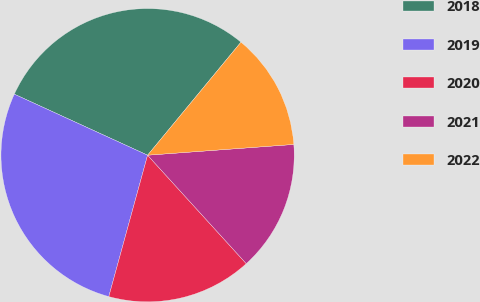Convert chart. <chart><loc_0><loc_0><loc_500><loc_500><pie_chart><fcel>2018<fcel>2019<fcel>2020<fcel>2021<fcel>2022<nl><fcel>29.15%<fcel>27.57%<fcel>16.01%<fcel>14.42%<fcel>12.84%<nl></chart> 